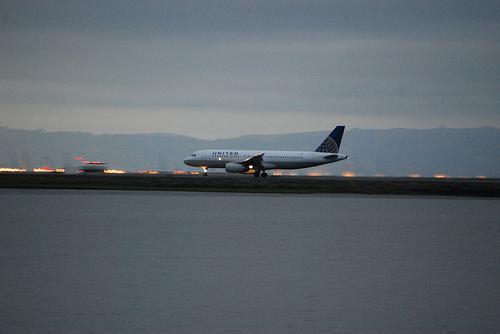How many planes are there?
Give a very brief answer. 1. 